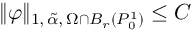Convert formula to latex. <formula><loc_0><loc_0><loc_500><loc_500>\| \varphi \| _ { 1 , \, \tilde { \alpha } , \, \Omega \cap B _ { r } ( P _ { 0 } ^ { 1 } ) } \leq C</formula> 